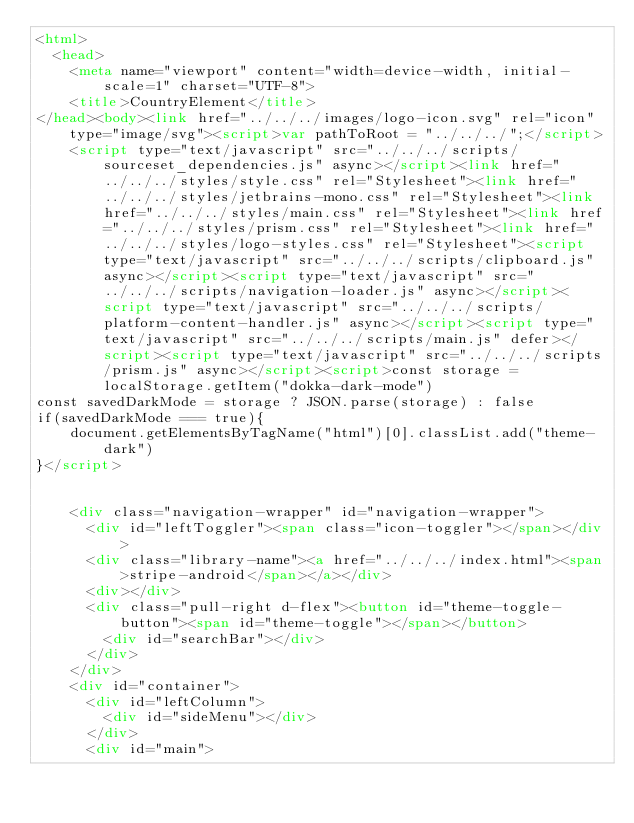<code> <loc_0><loc_0><loc_500><loc_500><_HTML_><html>
  <head>
    <meta name="viewport" content="width=device-width, initial-scale=1" charset="UTF-8">
    <title>CountryElement</title>
</head><body><link href="../../../images/logo-icon.svg" rel="icon" type="image/svg"><script>var pathToRoot = "../../../";</script>
    <script type="text/javascript" src="../../../scripts/sourceset_dependencies.js" async></script><link href="../../../styles/style.css" rel="Stylesheet"><link href="../../../styles/jetbrains-mono.css" rel="Stylesheet"><link href="../../../styles/main.css" rel="Stylesheet"><link href="../../../styles/prism.css" rel="Stylesheet"><link href="../../../styles/logo-styles.css" rel="Stylesheet"><script type="text/javascript" src="../../../scripts/clipboard.js" async></script><script type="text/javascript" src="../../../scripts/navigation-loader.js" async></script><script type="text/javascript" src="../../../scripts/platform-content-handler.js" async></script><script type="text/javascript" src="../../../scripts/main.js" defer></script><script type="text/javascript" src="../../../scripts/prism.js" async></script><script>const storage = localStorage.getItem("dokka-dark-mode")
const savedDarkMode = storage ? JSON.parse(storage) : false
if(savedDarkMode === true){
    document.getElementsByTagName("html")[0].classList.add("theme-dark")
}</script>

  
    <div class="navigation-wrapper" id="navigation-wrapper">
      <div id="leftToggler"><span class="icon-toggler"></span></div>
      <div class="library-name"><a href="../../../index.html"><span>stripe-android</span></a></div>
      <div></div>
      <div class="pull-right d-flex"><button id="theme-toggle-button"><span id="theme-toggle"></span></button>
        <div id="searchBar"></div>
      </div>
    </div>
    <div id="container">
      <div id="leftColumn">
        <div id="sideMenu"></div>
      </div>
      <div id="main"></code> 